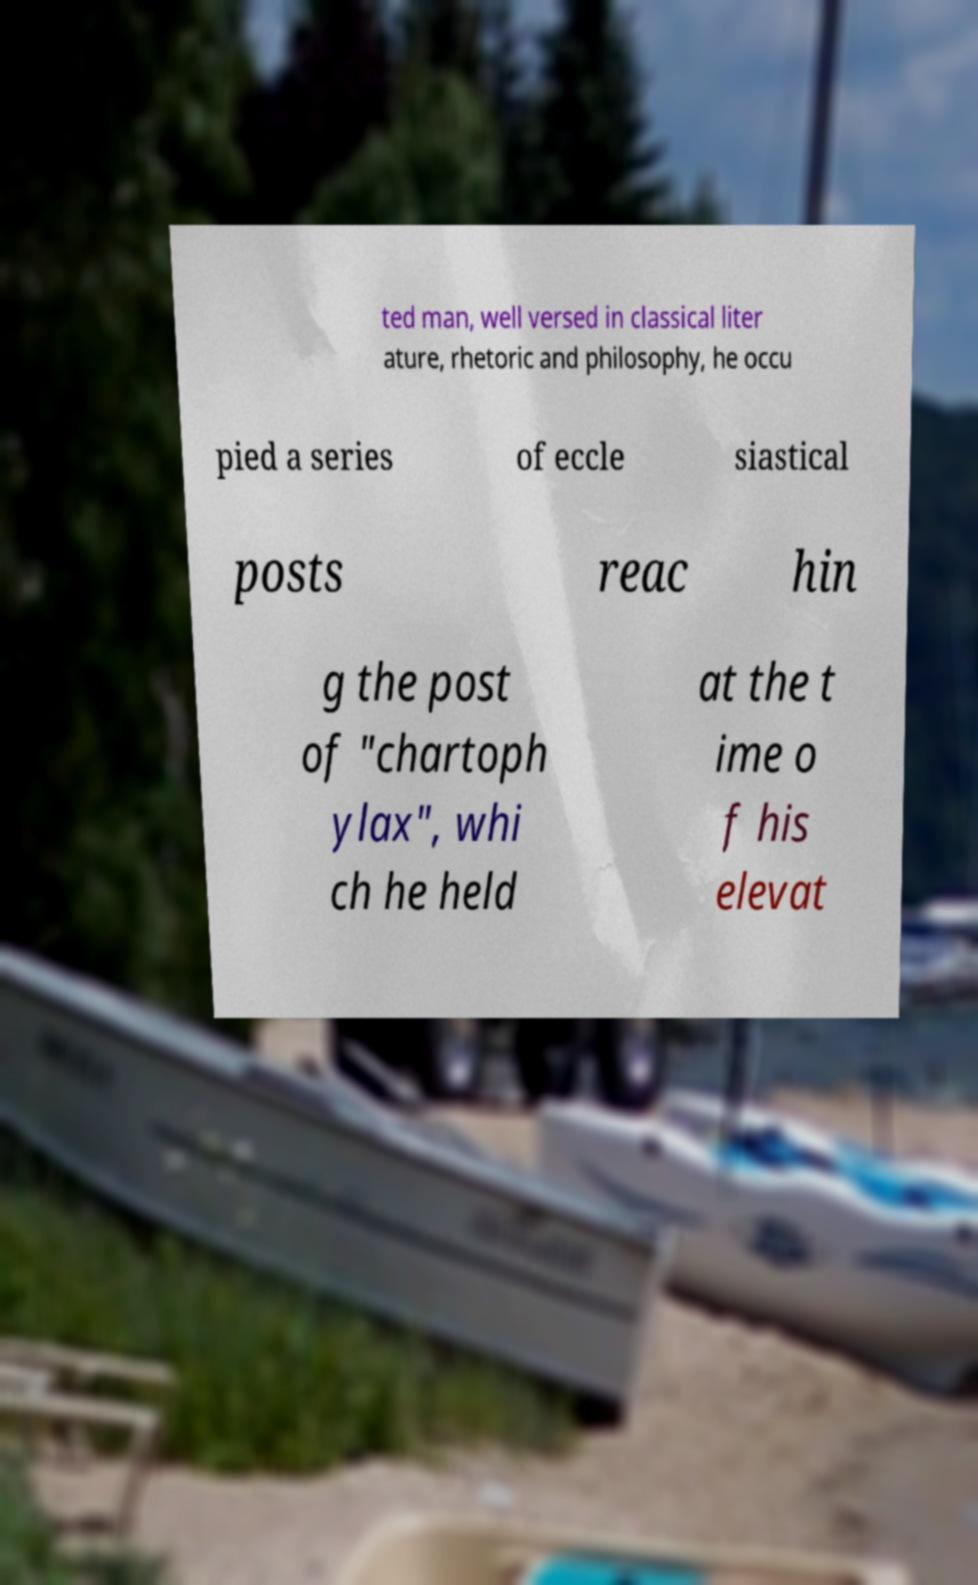Please identify and transcribe the text found in this image. ted man, well versed in classical liter ature, rhetoric and philosophy, he occu pied a series of eccle siastical posts reac hin g the post of "chartoph ylax", whi ch he held at the t ime o f his elevat 